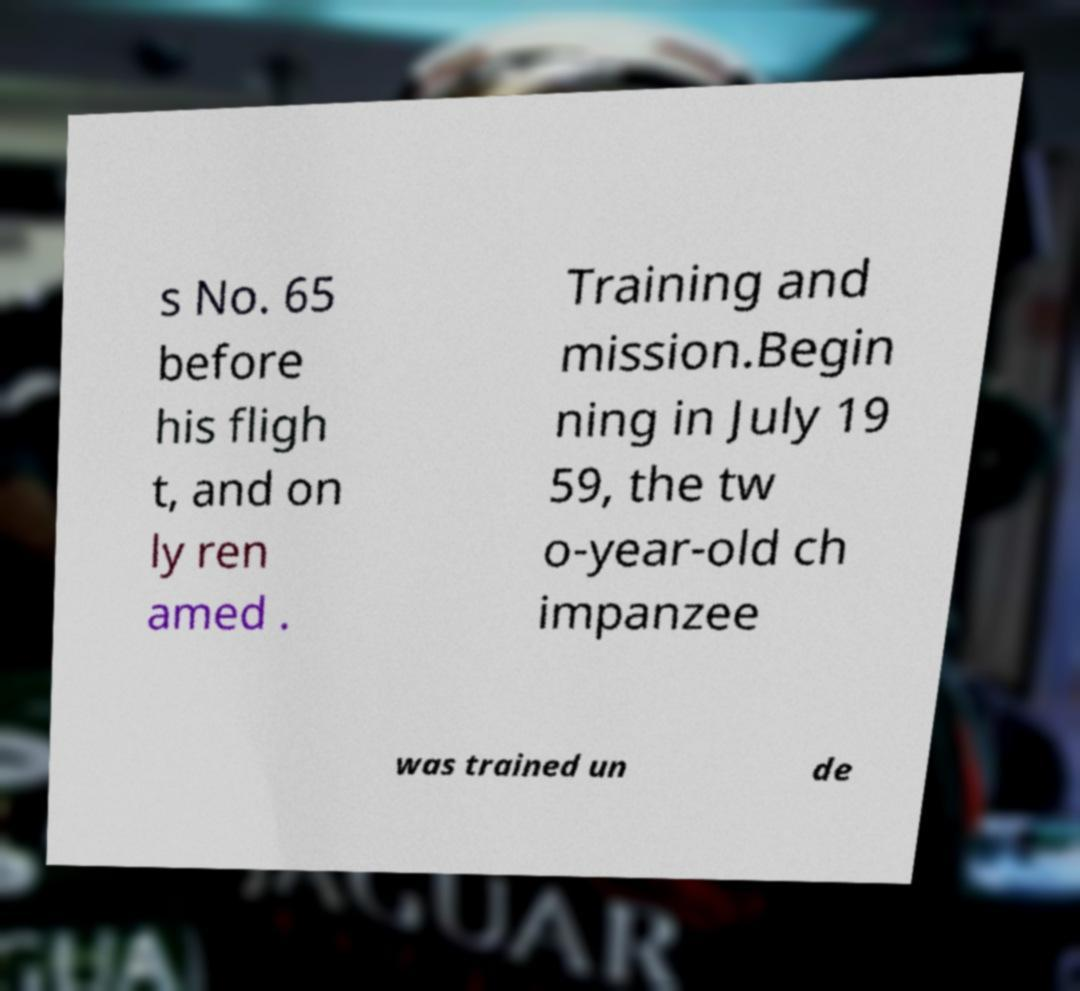Could you extract and type out the text from this image? s No. 65 before his fligh t, and on ly ren amed . Training and mission.Begin ning in July 19 59, the tw o-year-old ch impanzee was trained un de 